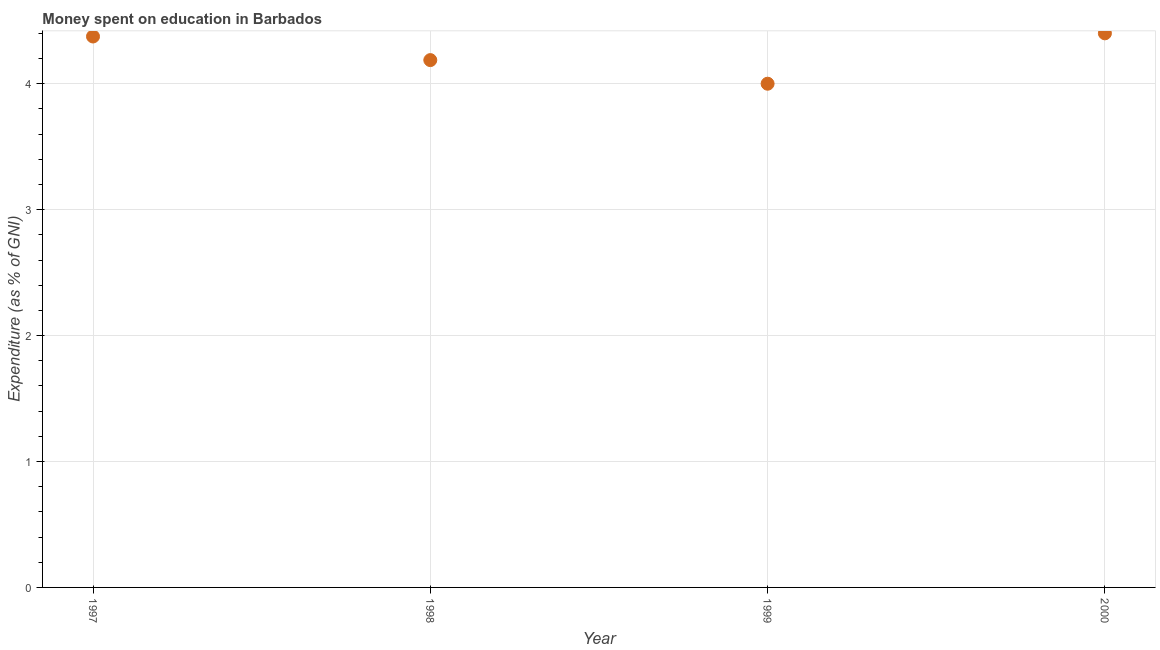In which year was the expenditure on education minimum?
Give a very brief answer. 1999. What is the sum of the expenditure on education?
Ensure brevity in your answer.  16.96. What is the difference between the expenditure on education in 1998 and 1999?
Make the answer very short. 0.19. What is the average expenditure on education per year?
Provide a short and direct response. 4.24. What is the median expenditure on education?
Give a very brief answer. 4.28. In how many years, is the expenditure on education greater than 3.8 %?
Offer a very short reply. 4. Do a majority of the years between 1997 and 1999 (inclusive) have expenditure on education greater than 3.6 %?
Ensure brevity in your answer.  Yes. What is the ratio of the expenditure on education in 1999 to that in 2000?
Your answer should be very brief. 0.91. What is the difference between the highest and the second highest expenditure on education?
Ensure brevity in your answer.  0.02. What is the difference between the highest and the lowest expenditure on education?
Offer a terse response. 0.4. In how many years, is the expenditure on education greater than the average expenditure on education taken over all years?
Offer a terse response. 2. Does the expenditure on education monotonically increase over the years?
Give a very brief answer. No. How many dotlines are there?
Your response must be concise. 1. What is the difference between two consecutive major ticks on the Y-axis?
Offer a very short reply. 1. Are the values on the major ticks of Y-axis written in scientific E-notation?
Your answer should be very brief. No. Does the graph contain any zero values?
Provide a short and direct response. No. What is the title of the graph?
Your answer should be compact. Money spent on education in Barbados. What is the label or title of the Y-axis?
Your answer should be very brief. Expenditure (as % of GNI). What is the Expenditure (as % of GNI) in 1997?
Provide a short and direct response. 4.38. What is the Expenditure (as % of GNI) in 1998?
Make the answer very short. 4.19. What is the Expenditure (as % of GNI) in 2000?
Provide a short and direct response. 4.4. What is the difference between the Expenditure (as % of GNI) in 1997 and 1998?
Offer a very short reply. 0.19. What is the difference between the Expenditure (as % of GNI) in 1997 and 2000?
Offer a terse response. -0.03. What is the difference between the Expenditure (as % of GNI) in 1998 and 1999?
Keep it short and to the point. 0.19. What is the difference between the Expenditure (as % of GNI) in 1998 and 2000?
Offer a very short reply. -0.21. What is the ratio of the Expenditure (as % of GNI) in 1997 to that in 1998?
Make the answer very short. 1.04. What is the ratio of the Expenditure (as % of GNI) in 1997 to that in 1999?
Your response must be concise. 1.09. What is the ratio of the Expenditure (as % of GNI) in 1998 to that in 1999?
Offer a terse response. 1.05. What is the ratio of the Expenditure (as % of GNI) in 1998 to that in 2000?
Offer a terse response. 0.95. What is the ratio of the Expenditure (as % of GNI) in 1999 to that in 2000?
Provide a succinct answer. 0.91. 